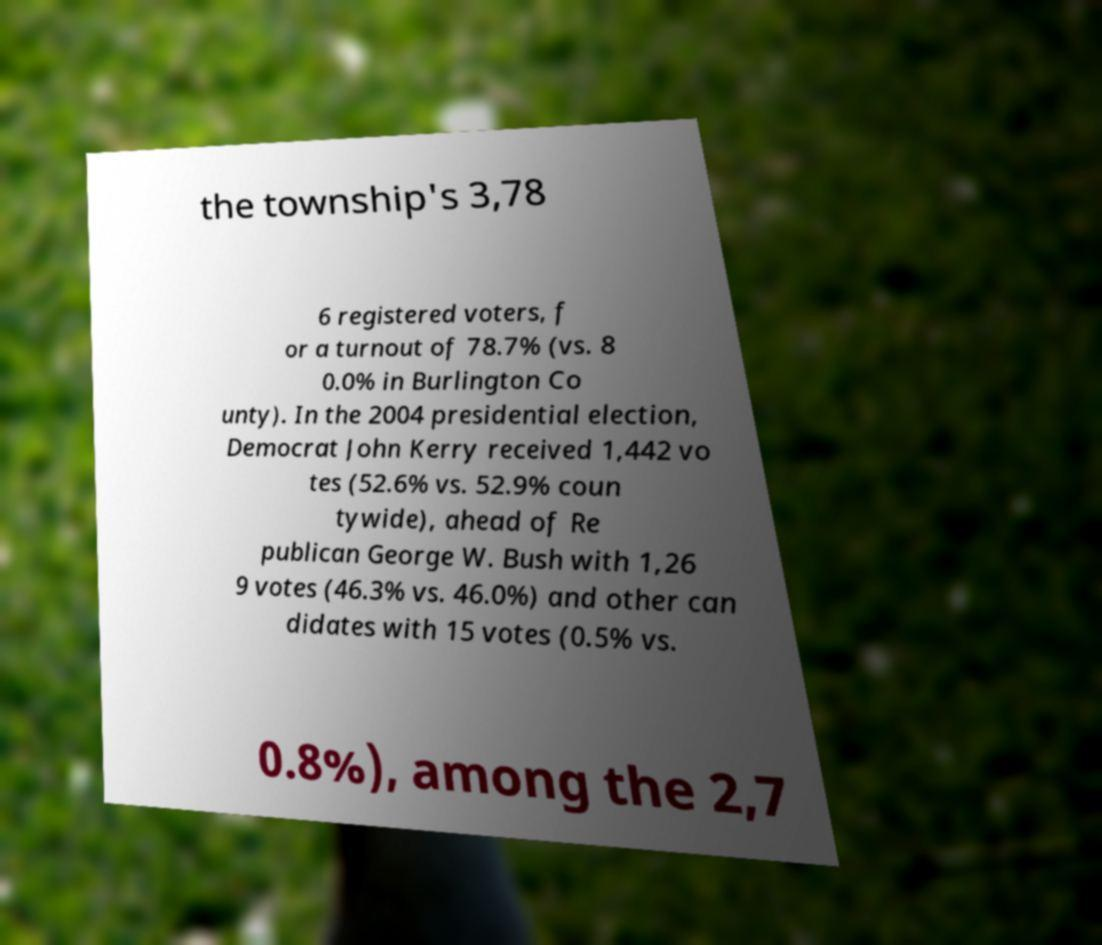Could you extract and type out the text from this image? the township's 3,78 6 registered voters, f or a turnout of 78.7% (vs. 8 0.0% in Burlington Co unty). In the 2004 presidential election, Democrat John Kerry received 1,442 vo tes (52.6% vs. 52.9% coun tywide), ahead of Re publican George W. Bush with 1,26 9 votes (46.3% vs. 46.0%) and other can didates with 15 votes (0.5% vs. 0.8%), among the 2,7 